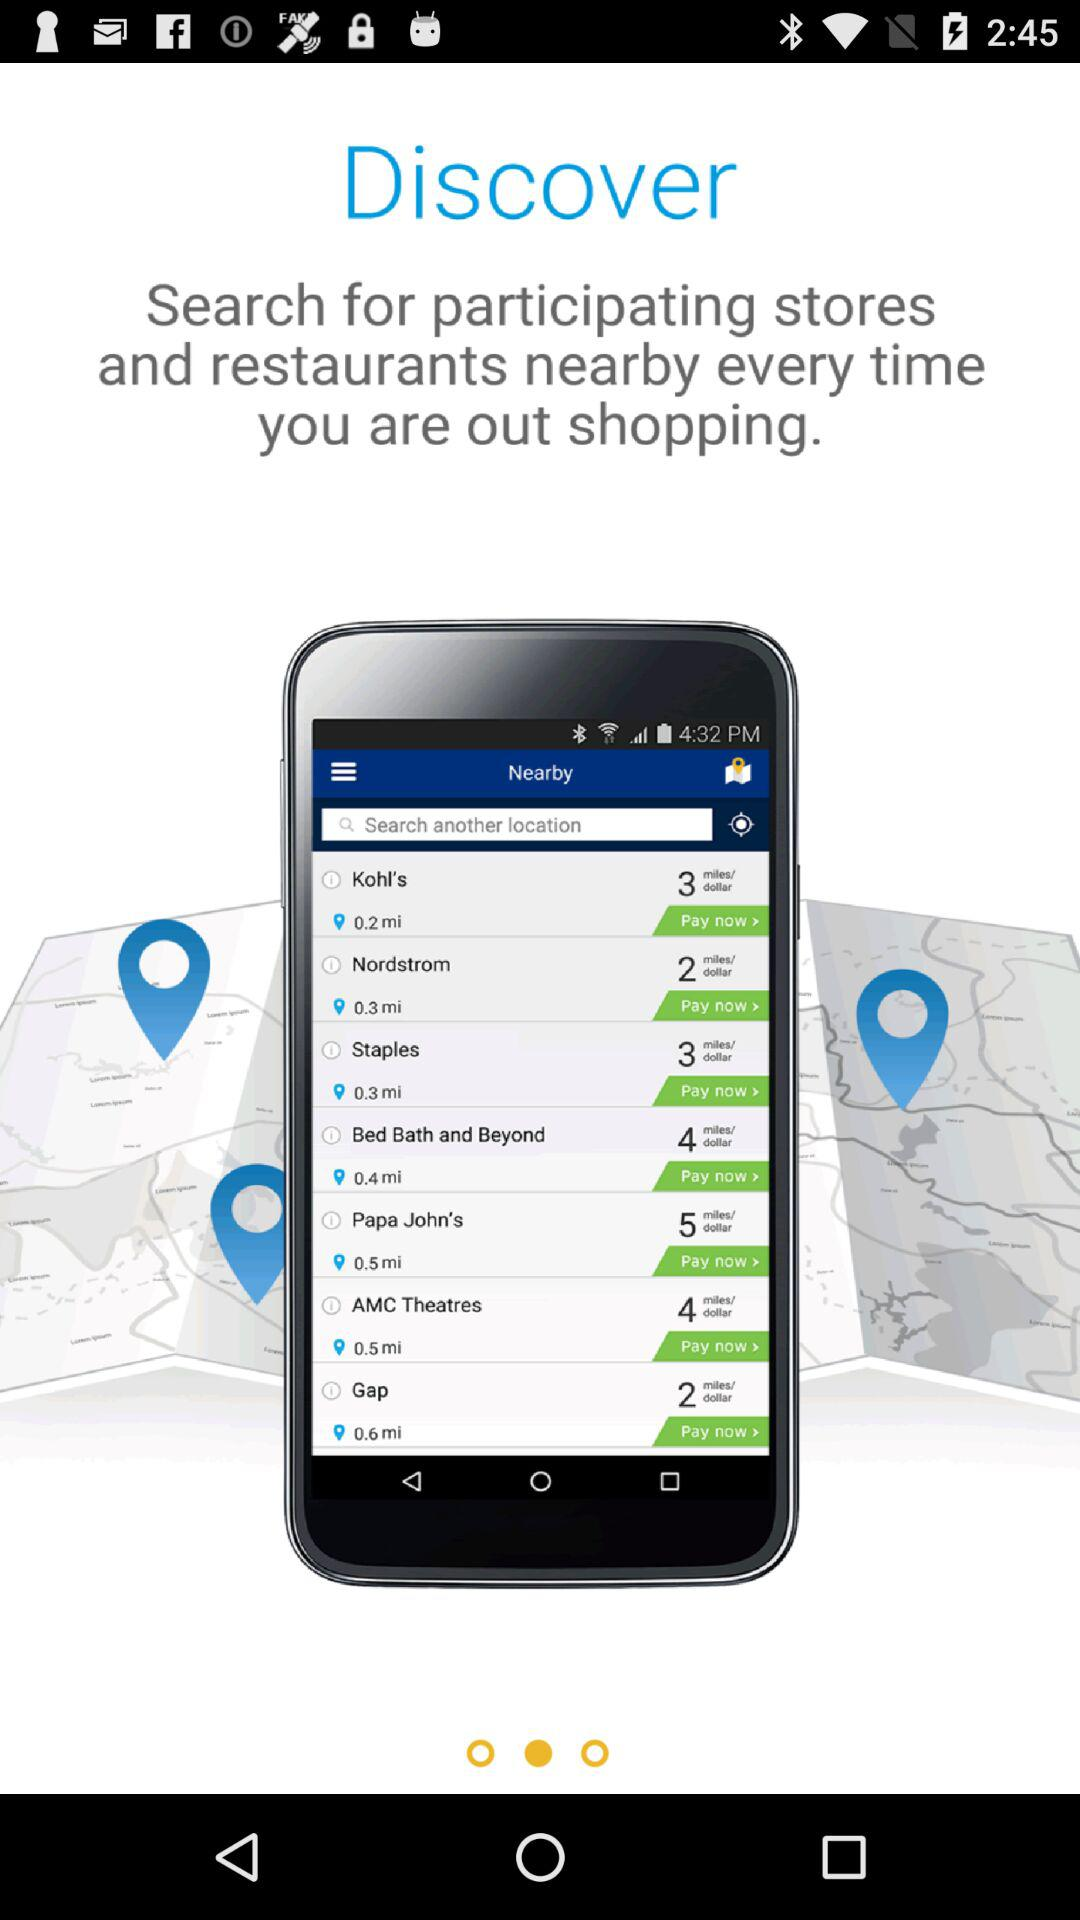What can we search for when we are out shopping? You can search for participating stores and restaurants nearby every time you go shopping. 